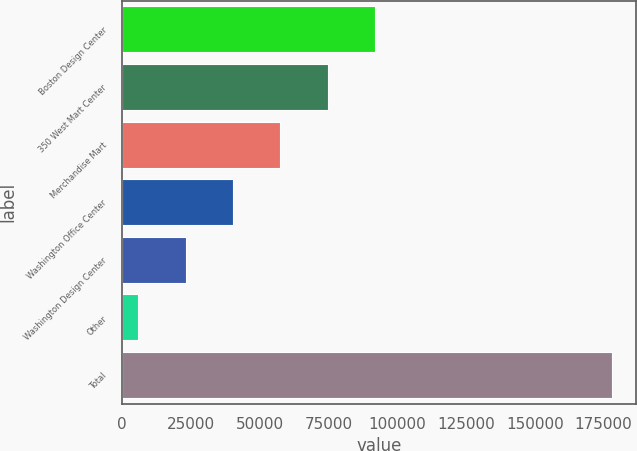Convert chart. <chart><loc_0><loc_0><loc_500><loc_500><bar_chart><fcel>Boston Design Center<fcel>350 West Mart Center<fcel>Merchandise Mart<fcel>Washington Office Center<fcel>Washington Design Center<fcel>Other<fcel>Total<nl><fcel>92000<fcel>74800<fcel>57600<fcel>40400<fcel>23200<fcel>6000<fcel>178000<nl></chart> 